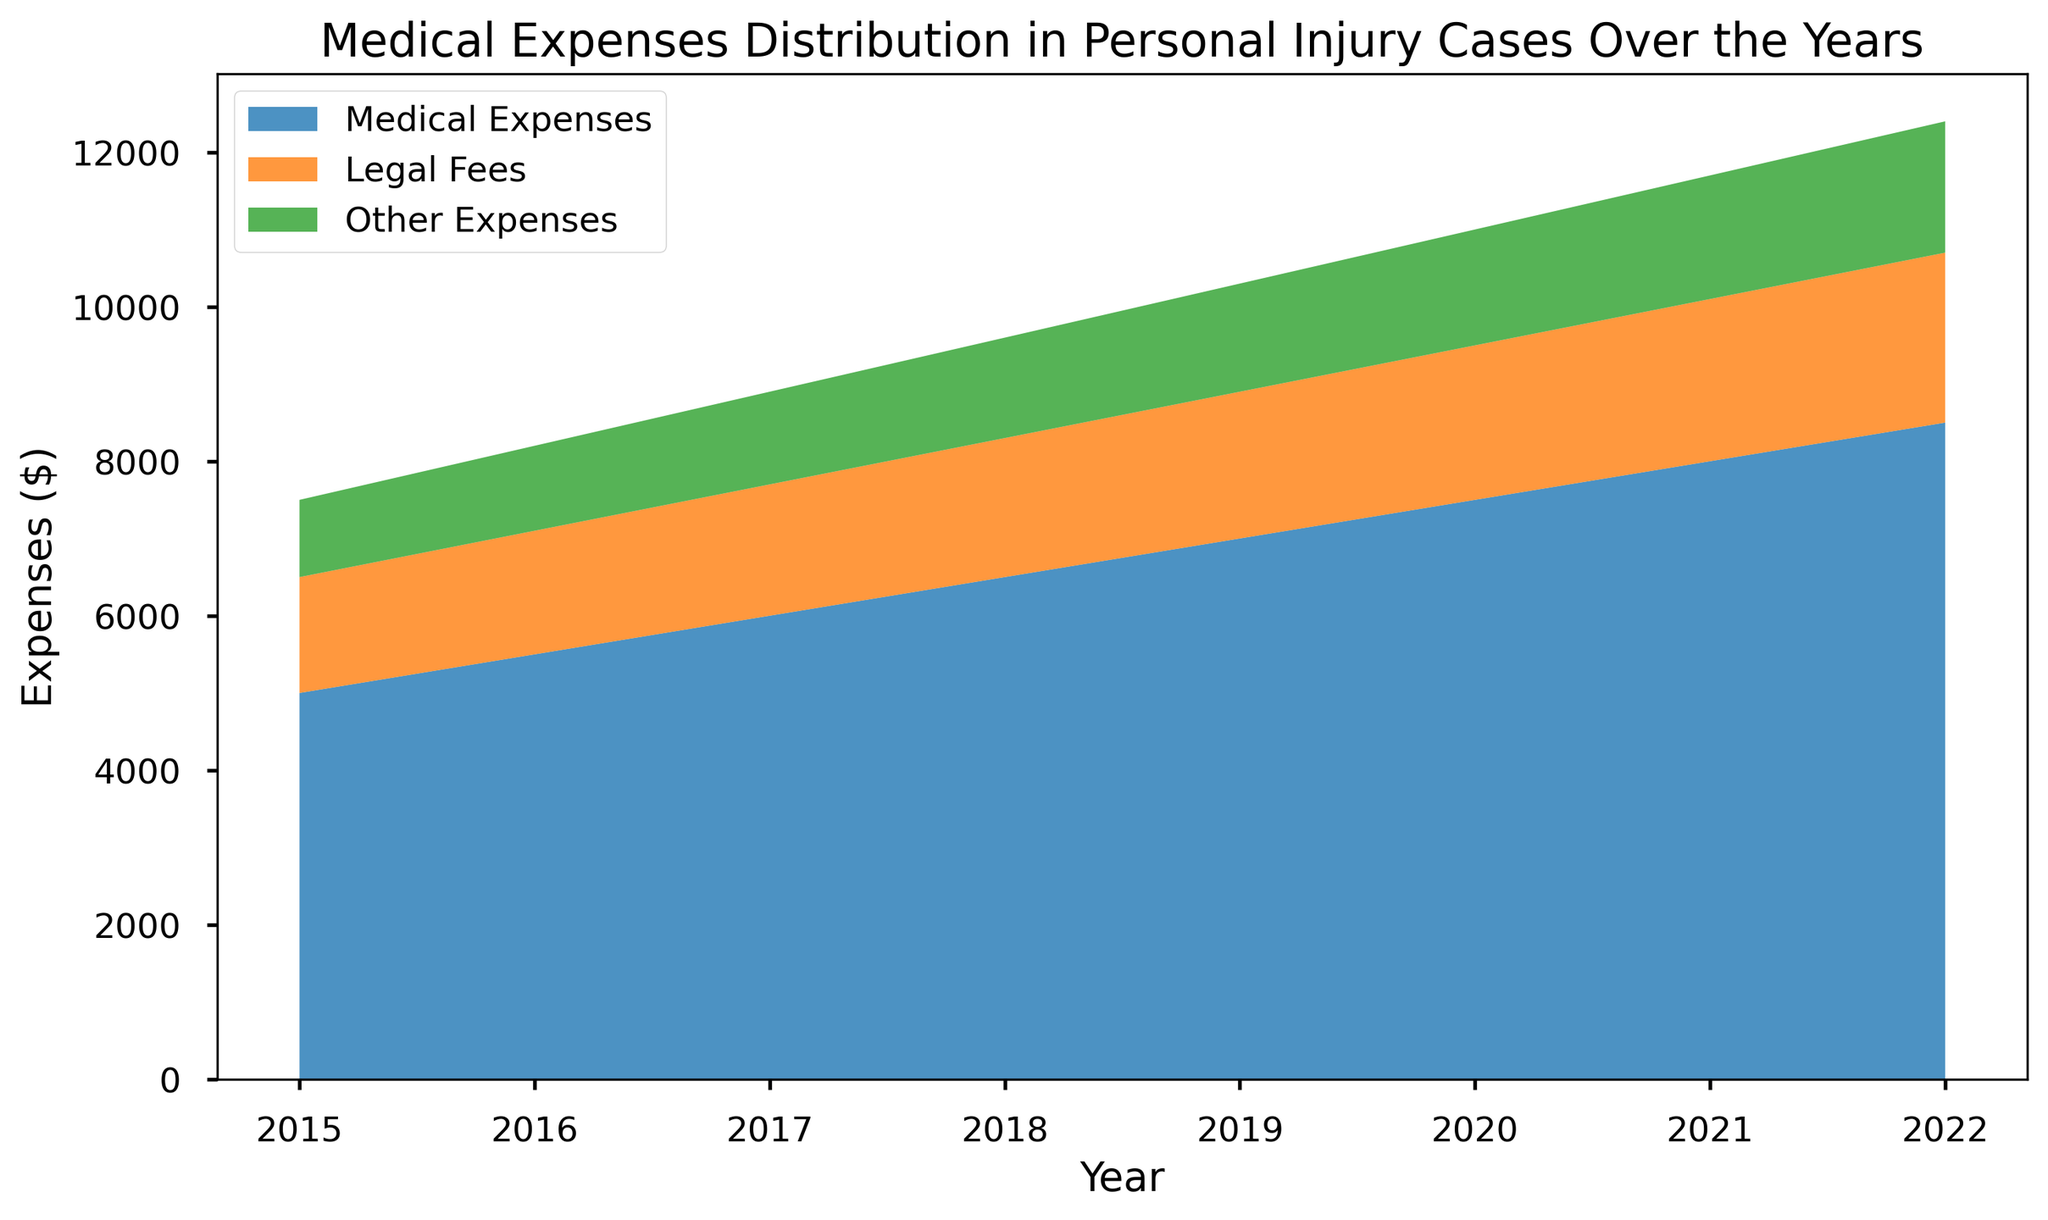What is the range of Medical Expenses from 2015 to 2022? The maximum value of Medical Expenses in 2022 is $8,500 and the minimum value in 2015 is $5,000. The range is calculated as $8,500 - $5,000 = $3,500
Answer: $3,500 Which year has the highest total expenses? To find the year with the highest total expenses, add up Medical Expenses, Legal Fees, and Other Expenses for each year. The year 2022 has the highest total expenses: $8,500 + $2,200 + $1,700 = $12,400
Answer: 2022 How do the Medical Expenses in 2020 compare to those in 2019? In 2019, the Medical Expenses are $7,000 and in 2020, they are $7,500. The Medical Expenses in 2020 are higher than those in 2019 by $500
Answer: $500 higher What is the average increase in Medical Expenses per year from 2015 to 2022? The increase in Medical Expenses from 2015 to 2022 is $8,500 - $5,000 = $3,500. There are 7 intervals (2022-2015). The average increase per year is $3,500 ÷ 7 = $500
Answer: $500 What are the components contributing to the total expenses in 2018? In 2018, the expenses are: Medical Expenses = $6,500, Legal Fees = $1,800, and Other Expenses = $1,300. Summing them gives the total expenses: $6,500 + $1,800 + $1,300 = $9,600
Answer: Medical Expenses: $6,500, Legal Fees: $1,800, Other Expenses: $1,300 During which year did the Other Expenses surpass $1,500? Observing the Other Expenses across the years, it surpasses $1,500 in 2020 with a value of $1,500 and goes higher thereafter
Answer: 2020 What portion of the total expenses in 2021 are Legal Fees? The total expenses in 2021 are $8,000 (Medical) + $2,100 (Legal) + $1,600 (Other) = $11,700. The portion taken by Legal Fees is $2,100 out of $11,700. Calculating the percentage: ($2,100 ÷ $11,700) × 100 ≈ 17.95%
Answer: 17.95% Identify the year with the smallest increase in Medical Expenses compared to the previous year. Observing the yearly increase: 
2016: $500,
2017: $500,
2018: $500,
2019: $500,
2020: $500,
2021: $500,
2022: $500; 
All years show the same increase of $500 in Medical Expenses
Answer: All years show the same increase 